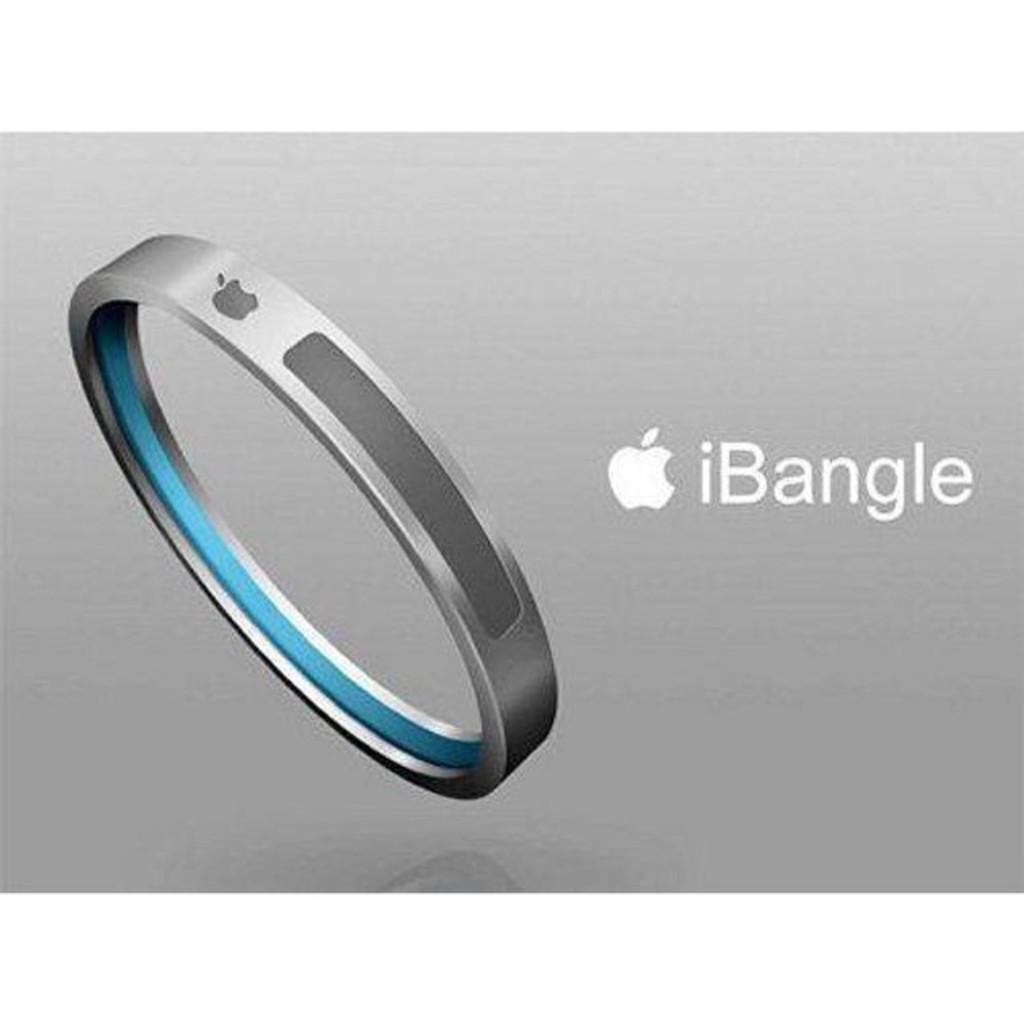What is the product name?
Give a very brief answer. Ibangle. 